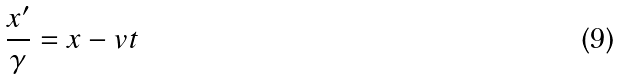<formula> <loc_0><loc_0><loc_500><loc_500>\frac { x ^ { \prime } } { \gamma } = x - v t</formula> 